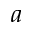Convert formula to latex. <formula><loc_0><loc_0><loc_500><loc_500>a</formula> 